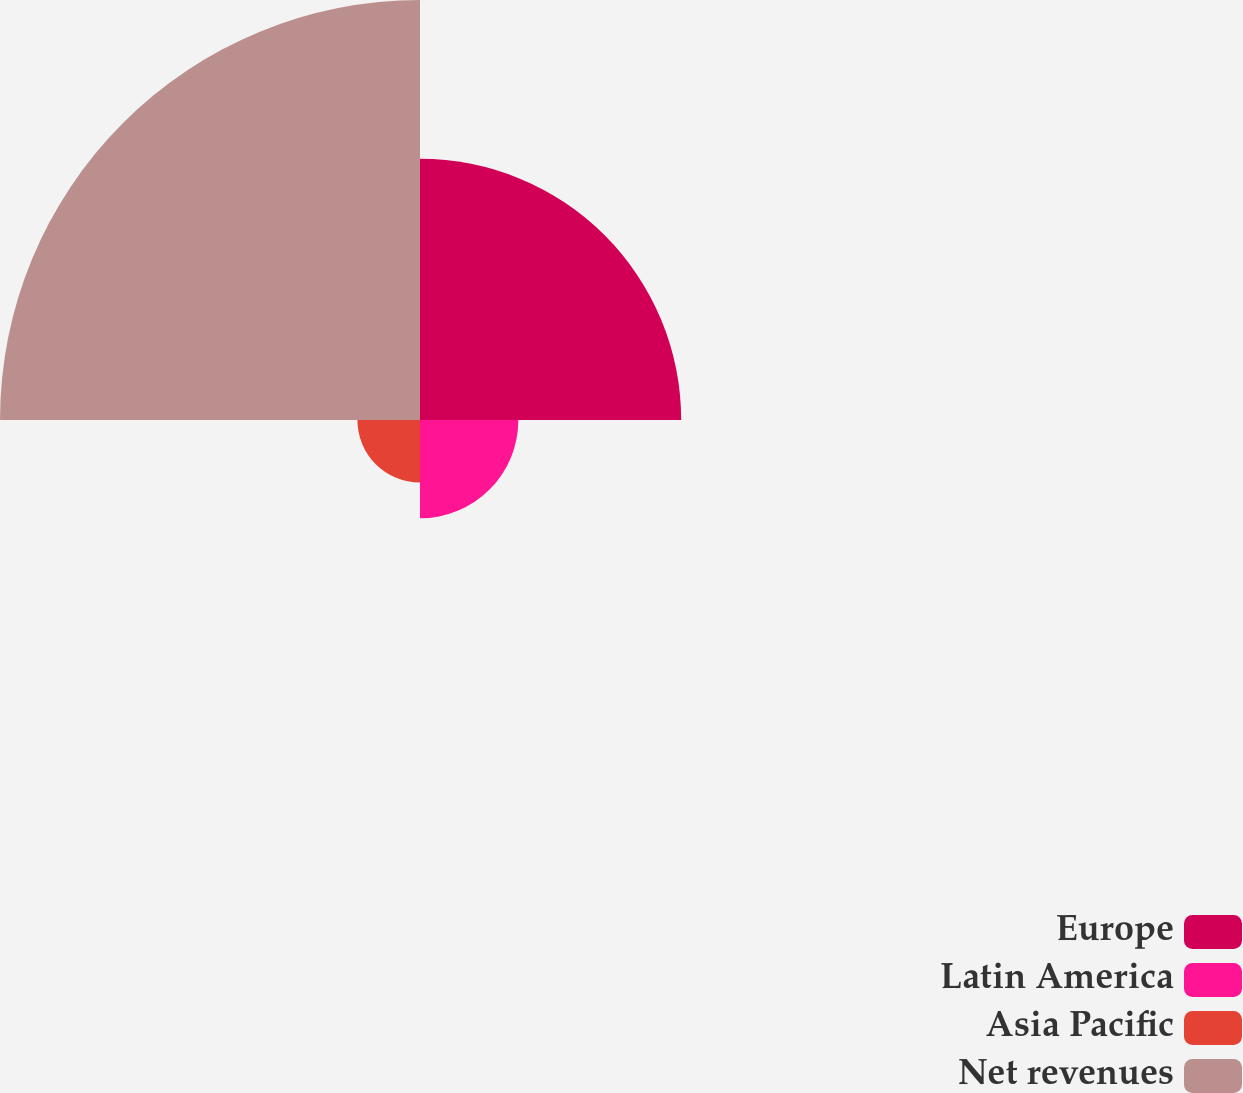<chart> <loc_0><loc_0><loc_500><loc_500><pie_chart><fcel>Europe<fcel>Latin America<fcel>Asia Pacific<fcel>Net revenues<nl><fcel>31.02%<fcel>11.68%<fcel>7.43%<fcel>49.88%<nl></chart> 